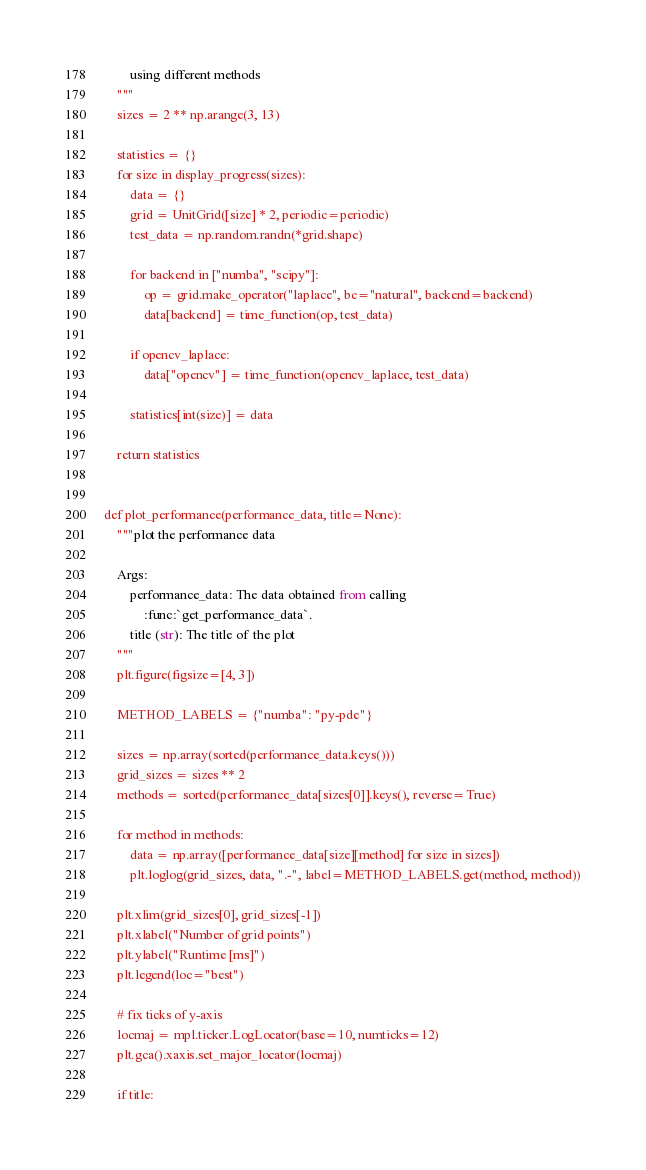<code> <loc_0><loc_0><loc_500><loc_500><_Python_>        using different methods
    """
    sizes = 2 ** np.arange(3, 13)

    statistics = {}
    for size in display_progress(sizes):
        data = {}
        grid = UnitGrid([size] * 2, periodic=periodic)
        test_data = np.random.randn(*grid.shape)

        for backend in ["numba", "scipy"]:
            op = grid.make_operator("laplace", bc="natural", backend=backend)
            data[backend] = time_function(op, test_data)

        if opencv_laplace:
            data["opencv"] = time_function(opencv_laplace, test_data)

        statistics[int(size)] = data

    return statistics


def plot_performance(performance_data, title=None):
    """plot the performance data

    Args:
        performance_data: The data obtained from calling
            :func:`get_performance_data`.
        title (str): The title of the plot
    """
    plt.figure(figsize=[4, 3])

    METHOD_LABELS = {"numba": "py-pde"}

    sizes = np.array(sorted(performance_data.keys()))
    grid_sizes = sizes ** 2
    methods = sorted(performance_data[sizes[0]].keys(), reverse=True)

    for method in methods:
        data = np.array([performance_data[size][method] for size in sizes])
        plt.loglog(grid_sizes, data, ".-", label=METHOD_LABELS.get(method, method))

    plt.xlim(grid_sizes[0], grid_sizes[-1])
    plt.xlabel("Number of grid points")
    plt.ylabel("Runtime [ms]")
    plt.legend(loc="best")

    # fix ticks of y-axis
    locmaj = mpl.ticker.LogLocator(base=10, numticks=12)
    plt.gca().xaxis.set_major_locator(locmaj)

    if title:</code> 